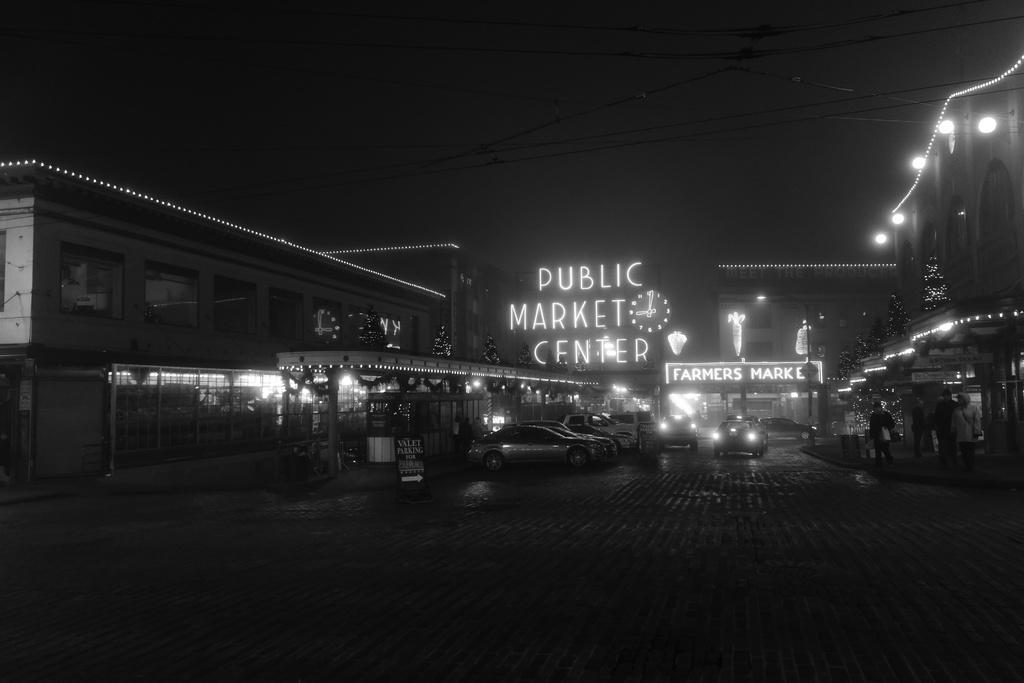What type of vehicles can be seen in the image? There are cars in the image. What structures are visible in the image? There are buildings in the image. What is the main pathway in the image? There is a road in the image. What is written or displayed in the image? There is text in the image. What natural elements can be seen in the image? There are trees in the image. What weather phenomenon is depicted in the image? There are lightnings in the image. How would you describe the overall lighting in the image? The background of the image is dark. Where is the mailbox located in the image? There is no mailbox present in the image. What type of polish is being applied to the cars in the image? There is no indication of any polish being applied to the cars in the image. 